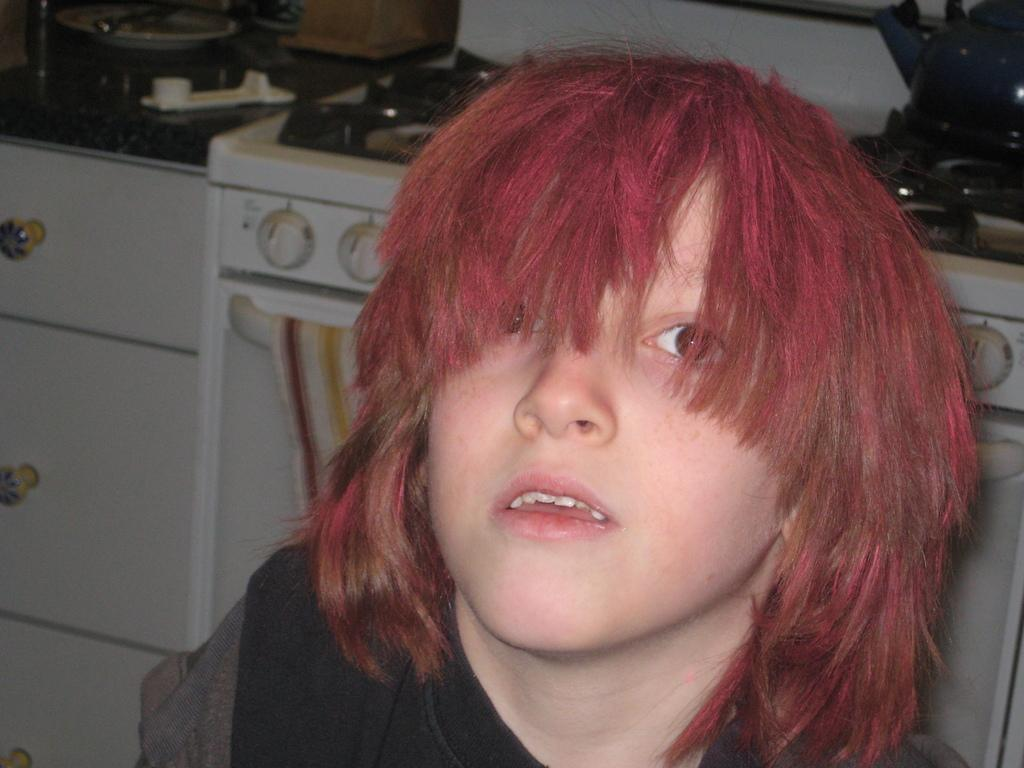Who or what is present in the image? There is a person in the image. What can be seen in the background of the image? There is a stove, cloth, cupboards, and other objects in the background of the image. Can you describe the stove in the background? The stove is a kitchen appliance used for cooking and heating food. What type of rings can be seen on the person's fingers in the image? There are no rings visible on the person's fingers in the image. What type of shoes is the person wearing in the image? There is no information about the person's footwear in the image. Is there any eggnog present in the image? There is no mention of eggnog in the image. 